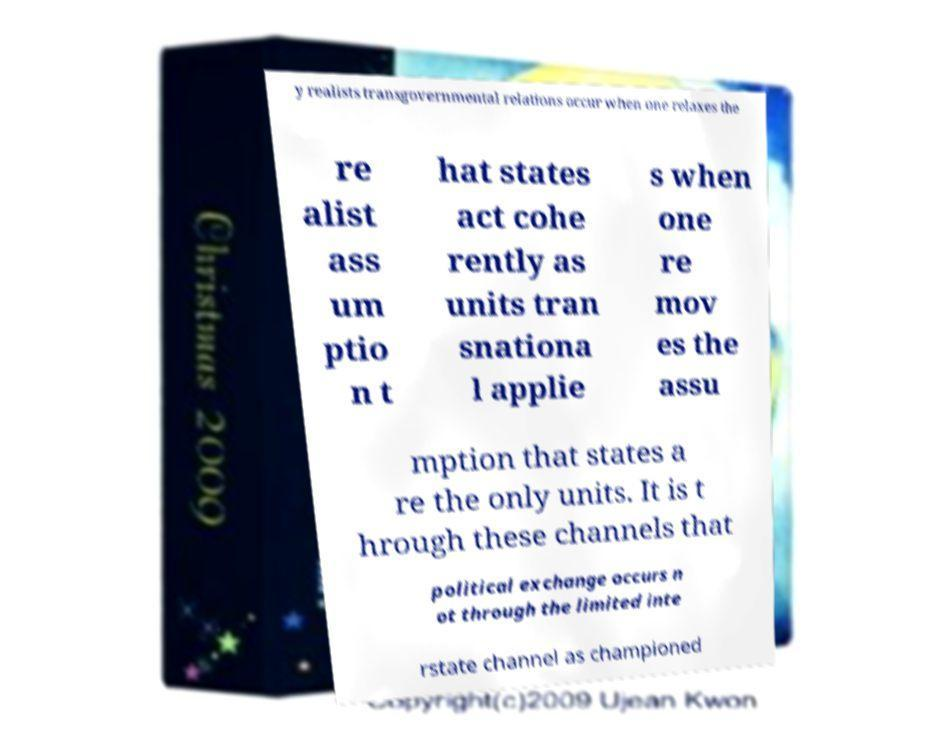Can you accurately transcribe the text from the provided image for me? y realists transgovernmental relations occur when one relaxes the re alist ass um ptio n t hat states act cohe rently as units tran snationa l applie s when one re mov es the assu mption that states a re the only units. It is t hrough these channels that political exchange occurs n ot through the limited inte rstate channel as championed 